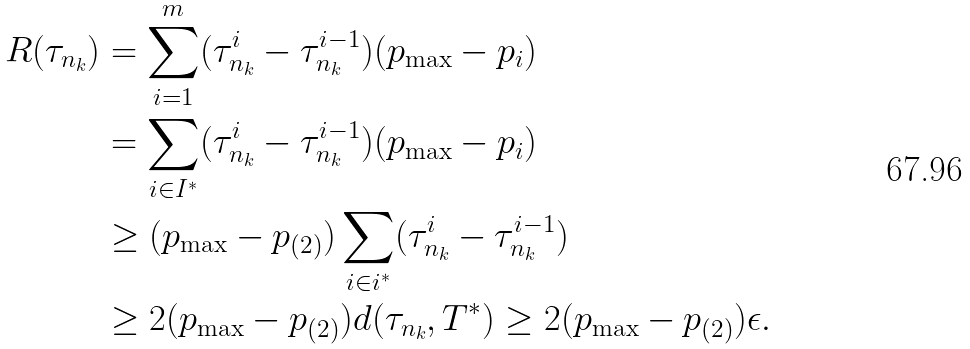<formula> <loc_0><loc_0><loc_500><loc_500>R ( \tau _ { n _ { k } } ) & = \sum ^ { m } _ { i = 1 } ( \tau ^ { i } _ { n _ { k } } - \tau ^ { i - 1 } _ { n _ { k } } ) ( p _ { \max } - p _ { i } ) \\ & = \sum _ { i \in I ^ { * } } ( \tau ^ { i } _ { n _ { k } } - \tau ^ { i - 1 } _ { n _ { k } } ) ( p _ { \max } - p _ { i } ) \\ & \geq ( p _ { \max } - p _ { ( 2 ) } ) \sum _ { i \in i ^ { * } } ( \tau ^ { i } _ { n _ { k } } - \tau ^ { i - 1 } _ { n _ { k } } ) \\ & \geq 2 ( p _ { \max } - p _ { ( 2 ) } ) d ( \tau _ { n _ { k } } , T ^ { * } ) \geq 2 ( p _ { \max } - p _ { ( 2 ) } ) \epsilon .</formula> 